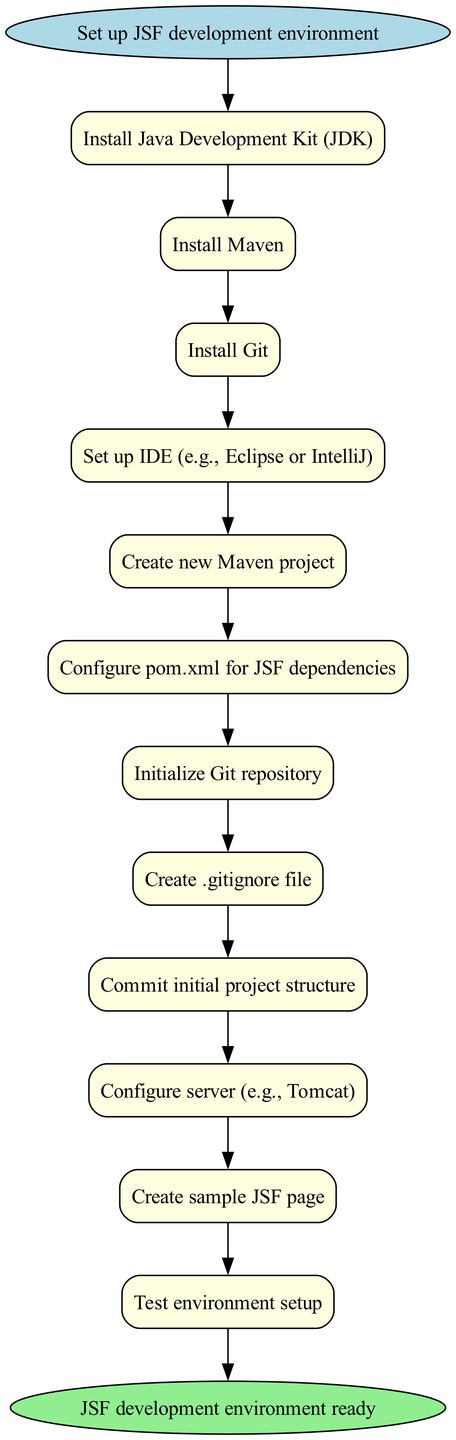What is the first step in setting up the JSF development environment? The first node in the flow chart indicates that the initial step is to "Install Java Development Kit (JDK)."
Answer: Install Java Development Kit (JDK) What is the last step in the setup process? The final action in the diagram shows that the last step is to "Test environment setup."
Answer: Test environment setup How many steps are there in total? There are 12 steps represented in the diagram, each leading sequentially from one activity to the next.
Answer: 12 What do you need to create after initializing the Git repository? After the Git repository is initialized, the next step is to "Create .gitignore file."
Answer: Create .gitignore file Which step comes immediately after configuring the `pom.xml` for JSF dependencies? The step that follows the configuration of the `pom.xml` is "Initialize Git repository," indicating a direct flow from one action to the next.
Answer: Initialize Git repository What are the two tools you must install before setting up the IDE? The flow chart specifies that you must first install "Java Development Kit (JDK)" and "Maven" before proceeding to set up the IDE.
Answer: Java Development Kit (JDK) and Maven Which step indicates setting up a necessary component for the JavaServer Faces application? The step labeled "Configure server (e.g., Tomcat)" denotes the setup of a crucial server component for running JSF applications.
Answer: Configure server (e.g., Tomcat) What step is linked directly before creating a new Maven project? The flow chart shows that "Set up IDE (e.g., Eclipse or IntelliJ)" is the step that directly precedes the creation of a new Maven project.
Answer: Set up IDE (e.g., Eclipse or IntelliJ) What action is represented by the very first edge from the start node? The first edge leads from the “Set up JSF development environment” start node to the step about installing the JDK, showing the initiation of the setup process.
Answer: Install Java Development Kit (JDK) 